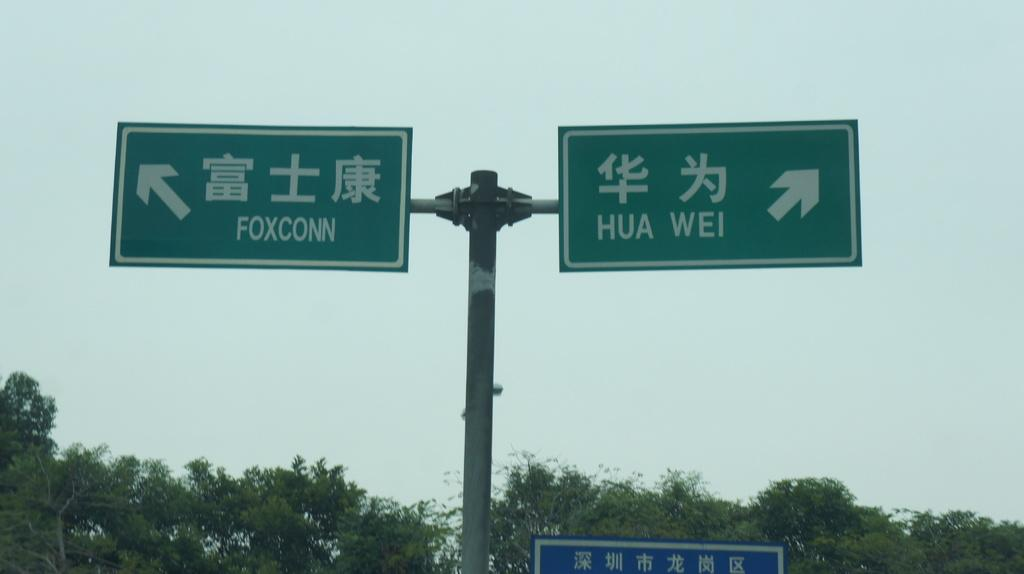<image>
Relay a brief, clear account of the picture shown. Two highway signs point in different directions, one towards Foxconn and the other towards Hua Wei. 